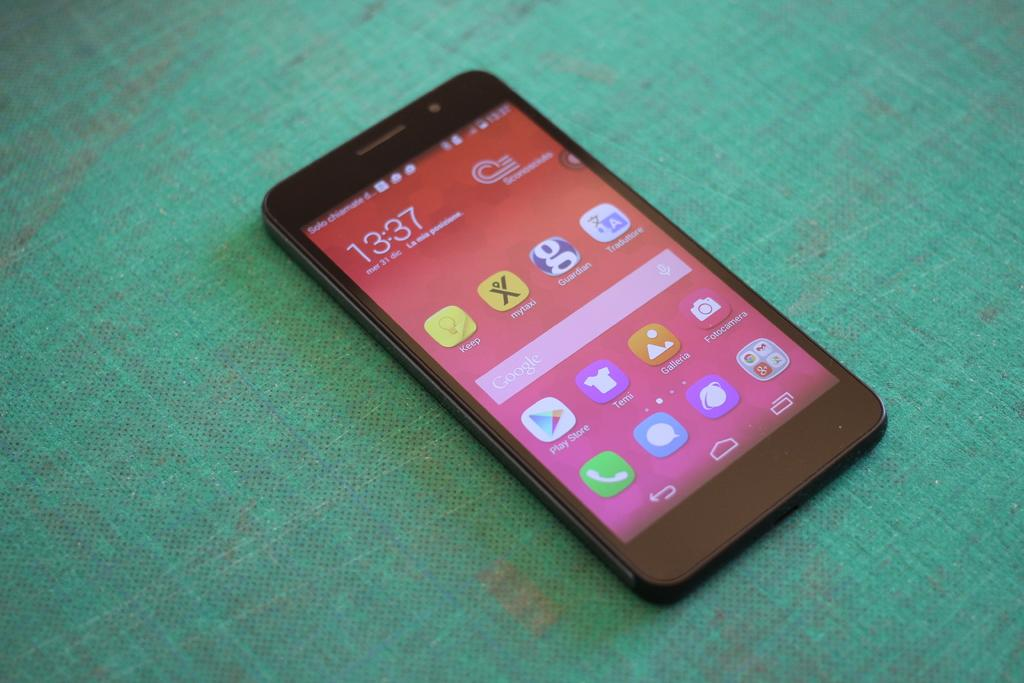<image>
Describe the image concisely. The screen with the clock reading 13:37 with icons for seeral apps like google play store. 